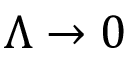Convert formula to latex. <formula><loc_0><loc_0><loc_500><loc_500>\Lambda \rightarrow 0</formula> 